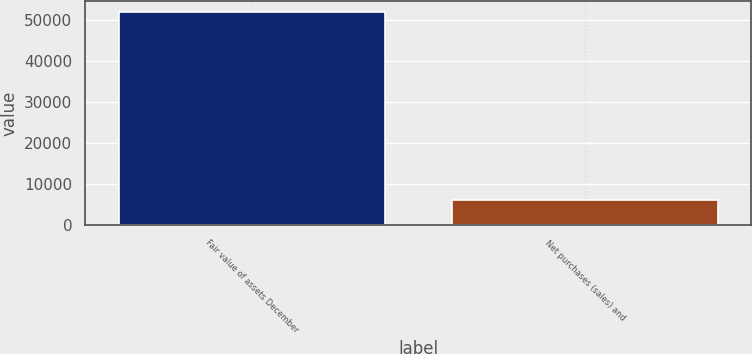<chart> <loc_0><loc_0><loc_500><loc_500><bar_chart><fcel>Fair value of assets December<fcel>Net purchases (sales) and<nl><fcel>51963<fcel>6150<nl></chart> 